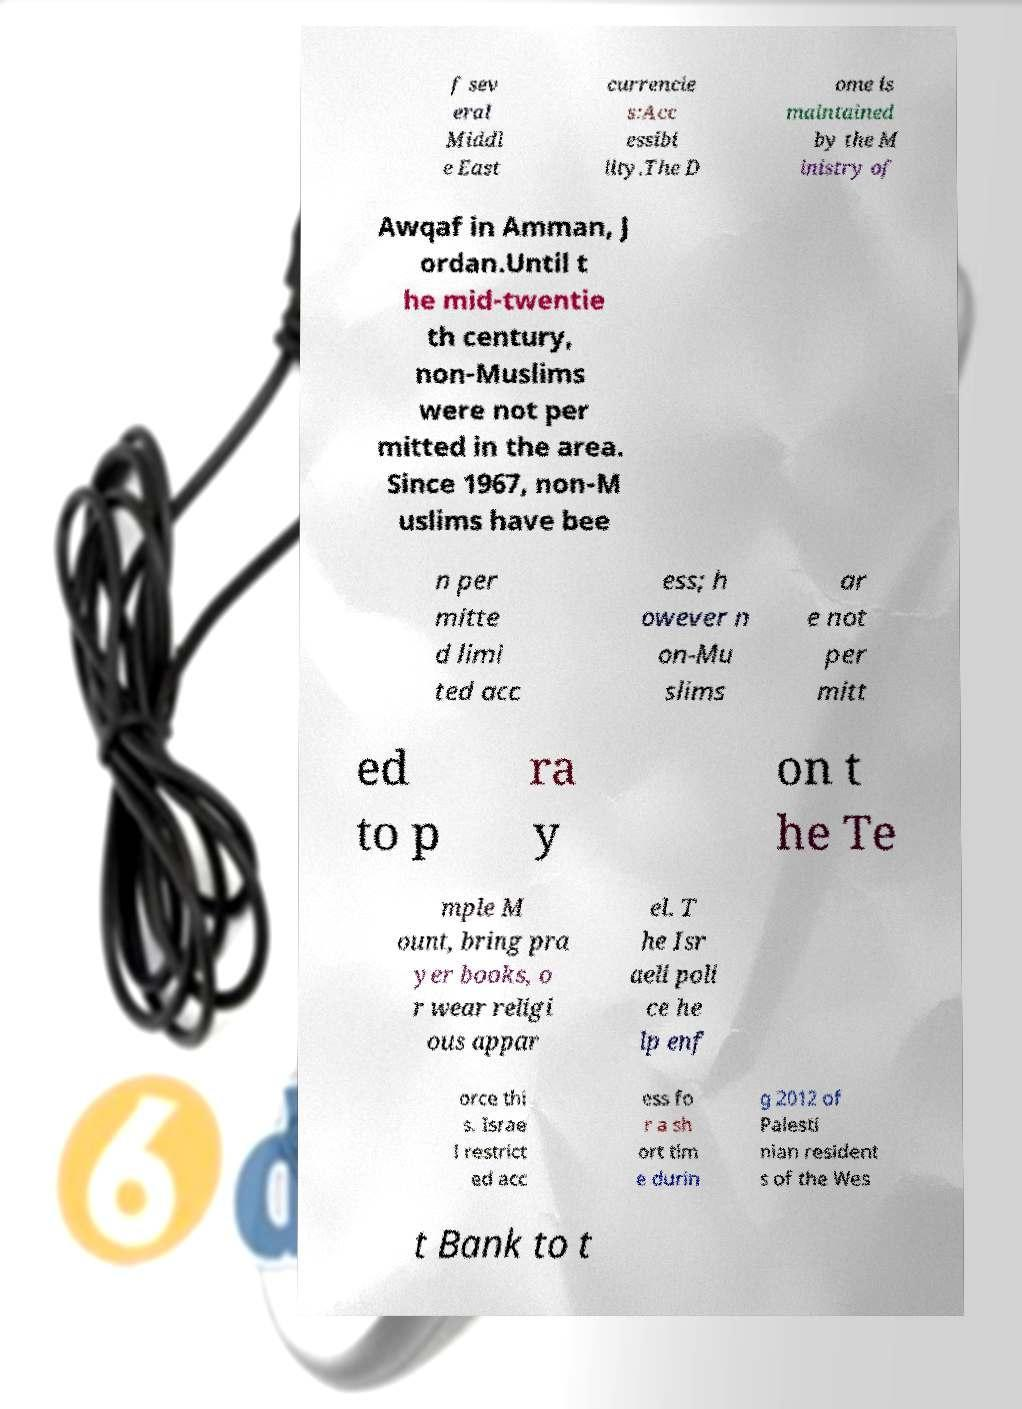Could you extract and type out the text from this image? f sev eral Middl e East currencie s:Acc essibi lity.The D ome is maintained by the M inistry of Awqaf in Amman, J ordan.Until t he mid-twentie th century, non-Muslims were not per mitted in the area. Since 1967, non-M uslims have bee n per mitte d limi ted acc ess; h owever n on-Mu slims ar e not per mitt ed to p ra y on t he Te mple M ount, bring pra yer books, o r wear religi ous appar el. T he Isr aeli poli ce he lp enf orce thi s. Israe l restrict ed acc ess fo r a sh ort tim e durin g 2012 of Palesti nian resident s of the Wes t Bank to t 